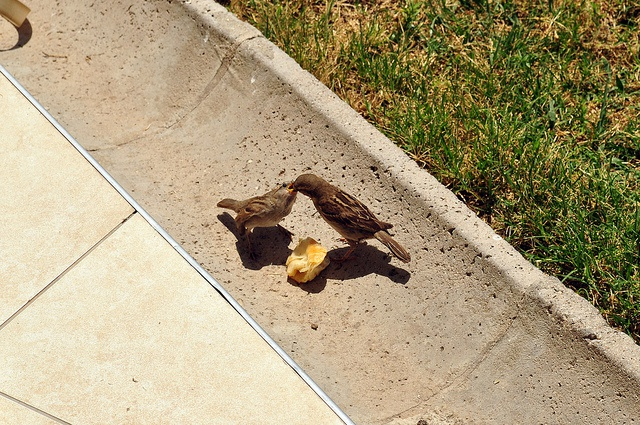Describe the objects in this image and their specific colors. I can see bird in olive, black, maroon, brown, and gray tones, bird in olive, maroon, brown, black, and gray tones, and orange in olive, khaki, orange, and gold tones in this image. 